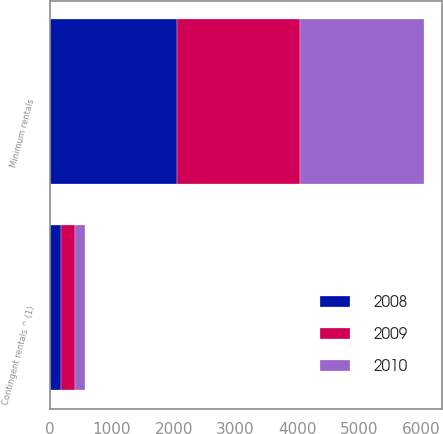Convert chart. <chart><loc_0><loc_0><loc_500><loc_500><stacked_bar_chart><ecel><fcel>Minimum rentals<fcel>Contingent rentals ^ (1)<nl><fcel>2010<fcel>2001<fcel>152<nl><fcel>2008<fcel>2047<fcel>181<nl><fcel>2009<fcel>1990<fcel>228<nl></chart> 